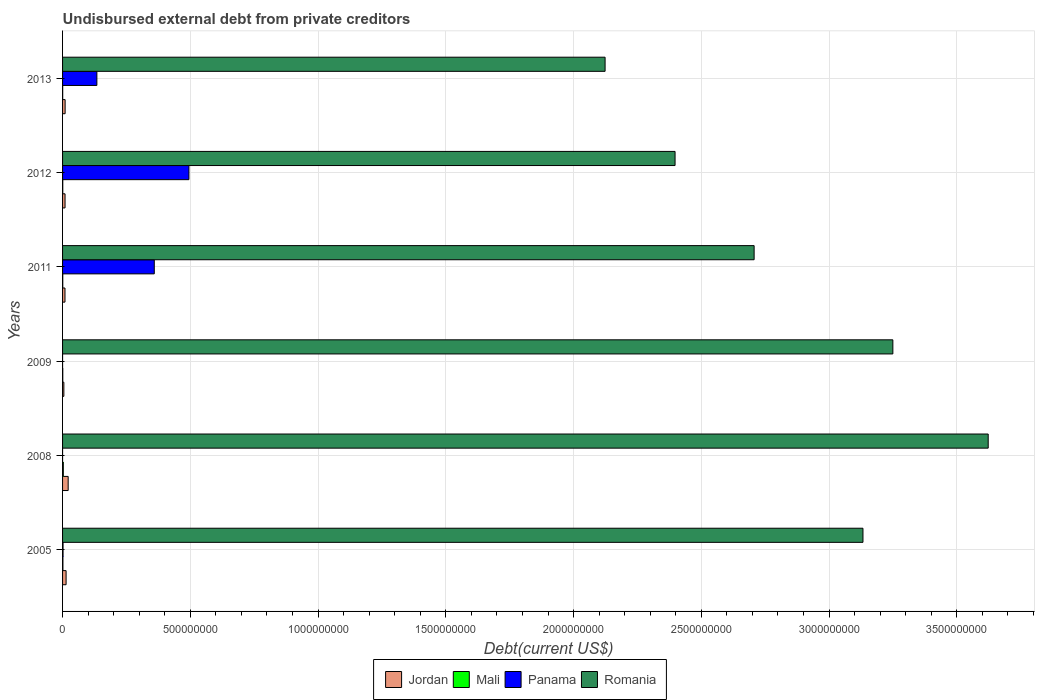How many groups of bars are there?
Offer a very short reply. 6. Are the number of bars on each tick of the Y-axis equal?
Your response must be concise. Yes. How many bars are there on the 2nd tick from the top?
Provide a short and direct response. 4. How many bars are there on the 6th tick from the bottom?
Offer a very short reply. 4. What is the total debt in Mali in 2005?
Make the answer very short. 1.38e+06. Across all years, what is the maximum total debt in Mali?
Ensure brevity in your answer.  2.91e+06. Across all years, what is the minimum total debt in Mali?
Give a very brief answer. 4.71e+05. What is the total total debt in Mali in the graph?
Provide a short and direct response. 7.16e+06. What is the difference between the total debt in Romania in 2008 and that in 2013?
Your answer should be very brief. 1.50e+09. What is the difference between the total debt in Jordan in 2005 and the total debt in Mali in 2012?
Your answer should be compact. 1.31e+07. What is the average total debt in Panama per year?
Offer a terse response. 1.65e+08. In the year 2011, what is the difference between the total debt in Romania and total debt in Mali?
Ensure brevity in your answer.  2.71e+09. In how many years, is the total debt in Romania greater than 1200000000 US$?
Your answer should be compact. 6. What is the ratio of the total debt in Mali in 2011 to that in 2013?
Your response must be concise. 1.61. Is the total debt in Romania in 2005 less than that in 2013?
Provide a short and direct response. No. Is the difference between the total debt in Romania in 2008 and 2012 greater than the difference between the total debt in Mali in 2008 and 2012?
Your answer should be compact. Yes. What is the difference between the highest and the second highest total debt in Jordan?
Offer a terse response. 8.09e+06. What is the difference between the highest and the lowest total debt in Romania?
Keep it short and to the point. 1.50e+09. In how many years, is the total debt in Romania greater than the average total debt in Romania taken over all years?
Offer a very short reply. 3. Is the sum of the total debt in Jordan in 2008 and 2013 greater than the maximum total debt in Romania across all years?
Ensure brevity in your answer.  No. What does the 3rd bar from the top in 2012 represents?
Ensure brevity in your answer.  Mali. What does the 1st bar from the bottom in 2005 represents?
Keep it short and to the point. Jordan. How many bars are there?
Ensure brevity in your answer.  24. Are all the bars in the graph horizontal?
Keep it short and to the point. Yes. How many years are there in the graph?
Provide a short and direct response. 6. What is the difference between two consecutive major ticks on the X-axis?
Ensure brevity in your answer.  5.00e+08. Does the graph contain any zero values?
Give a very brief answer. No. Where does the legend appear in the graph?
Provide a succinct answer. Bottom center. How many legend labels are there?
Your answer should be compact. 4. How are the legend labels stacked?
Your answer should be very brief. Horizontal. What is the title of the graph?
Keep it short and to the point. Undisbursed external debt from private creditors. Does "Bhutan" appear as one of the legend labels in the graph?
Give a very brief answer. No. What is the label or title of the X-axis?
Your answer should be very brief. Debt(current US$). What is the label or title of the Y-axis?
Provide a succinct answer. Years. What is the Debt(current US$) of Jordan in 2005?
Your response must be concise. 1.38e+07. What is the Debt(current US$) in Mali in 2005?
Your response must be concise. 1.38e+06. What is the Debt(current US$) of Panama in 2005?
Offer a terse response. 1.90e+06. What is the Debt(current US$) in Romania in 2005?
Provide a succinct answer. 3.13e+09. What is the Debt(current US$) of Jordan in 2008?
Your answer should be compact. 2.19e+07. What is the Debt(current US$) of Mali in 2008?
Offer a very short reply. 2.91e+06. What is the Debt(current US$) of Panama in 2008?
Make the answer very short. 2000. What is the Debt(current US$) of Romania in 2008?
Offer a terse response. 3.62e+09. What is the Debt(current US$) of Jordan in 2009?
Your answer should be very brief. 5.06e+06. What is the Debt(current US$) of Mali in 2009?
Keep it short and to the point. 8.62e+05. What is the Debt(current US$) in Panama in 2009?
Offer a very short reply. 2000. What is the Debt(current US$) in Romania in 2009?
Your answer should be compact. 3.25e+09. What is the Debt(current US$) of Jordan in 2011?
Provide a short and direct response. 9.48e+06. What is the Debt(current US$) in Mali in 2011?
Ensure brevity in your answer.  7.57e+05. What is the Debt(current US$) of Panama in 2011?
Your answer should be compact. 3.59e+08. What is the Debt(current US$) in Romania in 2011?
Offer a terse response. 2.71e+09. What is the Debt(current US$) in Jordan in 2012?
Your answer should be compact. 9.72e+06. What is the Debt(current US$) in Mali in 2012?
Give a very brief answer. 7.72e+05. What is the Debt(current US$) of Panama in 2012?
Your answer should be very brief. 4.95e+08. What is the Debt(current US$) in Romania in 2012?
Provide a succinct answer. 2.40e+09. What is the Debt(current US$) of Jordan in 2013?
Make the answer very short. 1.00e+07. What is the Debt(current US$) of Mali in 2013?
Offer a very short reply. 4.71e+05. What is the Debt(current US$) of Panama in 2013?
Provide a short and direct response. 1.34e+08. What is the Debt(current US$) in Romania in 2013?
Keep it short and to the point. 2.12e+09. Across all years, what is the maximum Debt(current US$) of Jordan?
Provide a short and direct response. 2.19e+07. Across all years, what is the maximum Debt(current US$) of Mali?
Offer a very short reply. 2.91e+06. Across all years, what is the maximum Debt(current US$) in Panama?
Your response must be concise. 4.95e+08. Across all years, what is the maximum Debt(current US$) of Romania?
Provide a short and direct response. 3.62e+09. Across all years, what is the minimum Debt(current US$) in Jordan?
Provide a short and direct response. 5.06e+06. Across all years, what is the minimum Debt(current US$) of Mali?
Your response must be concise. 4.71e+05. Across all years, what is the minimum Debt(current US$) of Panama?
Provide a succinct answer. 2000. Across all years, what is the minimum Debt(current US$) of Romania?
Ensure brevity in your answer.  2.12e+09. What is the total Debt(current US$) in Jordan in the graph?
Keep it short and to the point. 7.00e+07. What is the total Debt(current US$) of Mali in the graph?
Provide a short and direct response. 7.16e+06. What is the total Debt(current US$) in Panama in the graph?
Keep it short and to the point. 9.90e+08. What is the total Debt(current US$) of Romania in the graph?
Offer a very short reply. 1.72e+1. What is the difference between the Debt(current US$) in Jordan in 2005 and that in 2008?
Provide a short and direct response. -8.09e+06. What is the difference between the Debt(current US$) in Mali in 2005 and that in 2008?
Give a very brief answer. -1.52e+06. What is the difference between the Debt(current US$) of Panama in 2005 and that in 2008?
Ensure brevity in your answer.  1.90e+06. What is the difference between the Debt(current US$) in Romania in 2005 and that in 2008?
Keep it short and to the point. -4.90e+08. What is the difference between the Debt(current US$) of Jordan in 2005 and that in 2009?
Ensure brevity in your answer.  8.78e+06. What is the difference between the Debt(current US$) of Mali in 2005 and that in 2009?
Your response must be concise. 5.23e+05. What is the difference between the Debt(current US$) in Panama in 2005 and that in 2009?
Give a very brief answer. 1.90e+06. What is the difference between the Debt(current US$) of Romania in 2005 and that in 2009?
Your answer should be compact. -1.17e+08. What is the difference between the Debt(current US$) of Jordan in 2005 and that in 2011?
Keep it short and to the point. 4.36e+06. What is the difference between the Debt(current US$) in Mali in 2005 and that in 2011?
Provide a succinct answer. 6.28e+05. What is the difference between the Debt(current US$) in Panama in 2005 and that in 2011?
Ensure brevity in your answer.  -3.57e+08. What is the difference between the Debt(current US$) in Romania in 2005 and that in 2011?
Give a very brief answer. 4.26e+08. What is the difference between the Debt(current US$) of Jordan in 2005 and that in 2012?
Your answer should be compact. 4.12e+06. What is the difference between the Debt(current US$) of Mali in 2005 and that in 2012?
Offer a very short reply. 6.13e+05. What is the difference between the Debt(current US$) in Panama in 2005 and that in 2012?
Your answer should be very brief. -4.93e+08. What is the difference between the Debt(current US$) in Romania in 2005 and that in 2012?
Give a very brief answer. 7.35e+08. What is the difference between the Debt(current US$) in Jordan in 2005 and that in 2013?
Provide a succinct answer. 3.84e+06. What is the difference between the Debt(current US$) in Mali in 2005 and that in 2013?
Give a very brief answer. 9.14e+05. What is the difference between the Debt(current US$) of Panama in 2005 and that in 2013?
Offer a terse response. -1.32e+08. What is the difference between the Debt(current US$) in Romania in 2005 and that in 2013?
Your response must be concise. 1.01e+09. What is the difference between the Debt(current US$) in Jordan in 2008 and that in 2009?
Provide a short and direct response. 1.69e+07. What is the difference between the Debt(current US$) of Mali in 2008 and that in 2009?
Your answer should be very brief. 2.05e+06. What is the difference between the Debt(current US$) of Panama in 2008 and that in 2009?
Give a very brief answer. 0. What is the difference between the Debt(current US$) in Romania in 2008 and that in 2009?
Your answer should be compact. 3.73e+08. What is the difference between the Debt(current US$) of Jordan in 2008 and that in 2011?
Keep it short and to the point. 1.24e+07. What is the difference between the Debt(current US$) in Mali in 2008 and that in 2011?
Give a very brief answer. 2.15e+06. What is the difference between the Debt(current US$) of Panama in 2008 and that in 2011?
Make the answer very short. -3.59e+08. What is the difference between the Debt(current US$) of Romania in 2008 and that in 2011?
Provide a succinct answer. 9.16e+08. What is the difference between the Debt(current US$) in Jordan in 2008 and that in 2012?
Your answer should be compact. 1.22e+07. What is the difference between the Debt(current US$) in Mali in 2008 and that in 2012?
Your answer should be very brief. 2.14e+06. What is the difference between the Debt(current US$) in Panama in 2008 and that in 2012?
Provide a succinct answer. -4.95e+08. What is the difference between the Debt(current US$) of Romania in 2008 and that in 2012?
Your answer should be very brief. 1.23e+09. What is the difference between the Debt(current US$) of Jordan in 2008 and that in 2013?
Offer a terse response. 1.19e+07. What is the difference between the Debt(current US$) of Mali in 2008 and that in 2013?
Offer a terse response. 2.44e+06. What is the difference between the Debt(current US$) of Panama in 2008 and that in 2013?
Your response must be concise. -1.34e+08. What is the difference between the Debt(current US$) of Romania in 2008 and that in 2013?
Make the answer very short. 1.50e+09. What is the difference between the Debt(current US$) in Jordan in 2009 and that in 2011?
Offer a very short reply. -4.42e+06. What is the difference between the Debt(current US$) in Mali in 2009 and that in 2011?
Provide a succinct answer. 1.05e+05. What is the difference between the Debt(current US$) of Panama in 2009 and that in 2011?
Keep it short and to the point. -3.59e+08. What is the difference between the Debt(current US$) of Romania in 2009 and that in 2011?
Your answer should be compact. 5.43e+08. What is the difference between the Debt(current US$) of Jordan in 2009 and that in 2012?
Your answer should be compact. -4.66e+06. What is the difference between the Debt(current US$) of Panama in 2009 and that in 2012?
Provide a succinct answer. -4.95e+08. What is the difference between the Debt(current US$) in Romania in 2009 and that in 2012?
Your response must be concise. 8.52e+08. What is the difference between the Debt(current US$) of Jordan in 2009 and that in 2013?
Your answer should be compact. -4.94e+06. What is the difference between the Debt(current US$) of Mali in 2009 and that in 2013?
Provide a succinct answer. 3.91e+05. What is the difference between the Debt(current US$) of Panama in 2009 and that in 2013?
Keep it short and to the point. -1.34e+08. What is the difference between the Debt(current US$) in Romania in 2009 and that in 2013?
Keep it short and to the point. 1.13e+09. What is the difference between the Debt(current US$) of Jordan in 2011 and that in 2012?
Provide a succinct answer. -2.43e+05. What is the difference between the Debt(current US$) in Mali in 2011 and that in 2012?
Your answer should be very brief. -1.50e+04. What is the difference between the Debt(current US$) of Panama in 2011 and that in 2012?
Your answer should be very brief. -1.36e+08. What is the difference between the Debt(current US$) in Romania in 2011 and that in 2012?
Keep it short and to the point. 3.09e+08. What is the difference between the Debt(current US$) of Jordan in 2011 and that in 2013?
Offer a very short reply. -5.22e+05. What is the difference between the Debt(current US$) of Mali in 2011 and that in 2013?
Ensure brevity in your answer.  2.86e+05. What is the difference between the Debt(current US$) of Panama in 2011 and that in 2013?
Your response must be concise. 2.25e+08. What is the difference between the Debt(current US$) in Romania in 2011 and that in 2013?
Your answer should be very brief. 5.83e+08. What is the difference between the Debt(current US$) of Jordan in 2012 and that in 2013?
Your response must be concise. -2.79e+05. What is the difference between the Debt(current US$) of Mali in 2012 and that in 2013?
Offer a terse response. 3.01e+05. What is the difference between the Debt(current US$) of Panama in 2012 and that in 2013?
Provide a succinct answer. 3.60e+08. What is the difference between the Debt(current US$) in Romania in 2012 and that in 2013?
Keep it short and to the point. 2.74e+08. What is the difference between the Debt(current US$) of Jordan in 2005 and the Debt(current US$) of Mali in 2008?
Provide a short and direct response. 1.09e+07. What is the difference between the Debt(current US$) of Jordan in 2005 and the Debt(current US$) of Panama in 2008?
Give a very brief answer. 1.38e+07. What is the difference between the Debt(current US$) in Jordan in 2005 and the Debt(current US$) in Romania in 2008?
Provide a short and direct response. -3.61e+09. What is the difference between the Debt(current US$) of Mali in 2005 and the Debt(current US$) of Panama in 2008?
Offer a terse response. 1.38e+06. What is the difference between the Debt(current US$) of Mali in 2005 and the Debt(current US$) of Romania in 2008?
Provide a succinct answer. -3.62e+09. What is the difference between the Debt(current US$) of Panama in 2005 and the Debt(current US$) of Romania in 2008?
Offer a terse response. -3.62e+09. What is the difference between the Debt(current US$) of Jordan in 2005 and the Debt(current US$) of Mali in 2009?
Offer a very short reply. 1.30e+07. What is the difference between the Debt(current US$) of Jordan in 2005 and the Debt(current US$) of Panama in 2009?
Make the answer very short. 1.38e+07. What is the difference between the Debt(current US$) in Jordan in 2005 and the Debt(current US$) in Romania in 2009?
Your answer should be compact. -3.24e+09. What is the difference between the Debt(current US$) of Mali in 2005 and the Debt(current US$) of Panama in 2009?
Offer a terse response. 1.38e+06. What is the difference between the Debt(current US$) in Mali in 2005 and the Debt(current US$) in Romania in 2009?
Make the answer very short. -3.25e+09. What is the difference between the Debt(current US$) in Panama in 2005 and the Debt(current US$) in Romania in 2009?
Give a very brief answer. -3.25e+09. What is the difference between the Debt(current US$) in Jordan in 2005 and the Debt(current US$) in Mali in 2011?
Provide a short and direct response. 1.31e+07. What is the difference between the Debt(current US$) in Jordan in 2005 and the Debt(current US$) in Panama in 2011?
Make the answer very short. -3.45e+08. What is the difference between the Debt(current US$) in Jordan in 2005 and the Debt(current US$) in Romania in 2011?
Provide a short and direct response. -2.69e+09. What is the difference between the Debt(current US$) in Mali in 2005 and the Debt(current US$) in Panama in 2011?
Provide a short and direct response. -3.58e+08. What is the difference between the Debt(current US$) of Mali in 2005 and the Debt(current US$) of Romania in 2011?
Your answer should be very brief. -2.71e+09. What is the difference between the Debt(current US$) of Panama in 2005 and the Debt(current US$) of Romania in 2011?
Offer a terse response. -2.70e+09. What is the difference between the Debt(current US$) of Jordan in 2005 and the Debt(current US$) of Mali in 2012?
Offer a terse response. 1.31e+07. What is the difference between the Debt(current US$) in Jordan in 2005 and the Debt(current US$) in Panama in 2012?
Your response must be concise. -4.81e+08. What is the difference between the Debt(current US$) in Jordan in 2005 and the Debt(current US$) in Romania in 2012?
Ensure brevity in your answer.  -2.38e+09. What is the difference between the Debt(current US$) of Mali in 2005 and the Debt(current US$) of Panama in 2012?
Provide a succinct answer. -4.93e+08. What is the difference between the Debt(current US$) of Mali in 2005 and the Debt(current US$) of Romania in 2012?
Make the answer very short. -2.40e+09. What is the difference between the Debt(current US$) of Panama in 2005 and the Debt(current US$) of Romania in 2012?
Provide a succinct answer. -2.40e+09. What is the difference between the Debt(current US$) in Jordan in 2005 and the Debt(current US$) in Mali in 2013?
Give a very brief answer. 1.34e+07. What is the difference between the Debt(current US$) in Jordan in 2005 and the Debt(current US$) in Panama in 2013?
Ensure brevity in your answer.  -1.20e+08. What is the difference between the Debt(current US$) of Jordan in 2005 and the Debt(current US$) of Romania in 2013?
Make the answer very short. -2.11e+09. What is the difference between the Debt(current US$) in Mali in 2005 and the Debt(current US$) in Panama in 2013?
Your response must be concise. -1.33e+08. What is the difference between the Debt(current US$) of Mali in 2005 and the Debt(current US$) of Romania in 2013?
Provide a short and direct response. -2.12e+09. What is the difference between the Debt(current US$) of Panama in 2005 and the Debt(current US$) of Romania in 2013?
Your answer should be very brief. -2.12e+09. What is the difference between the Debt(current US$) in Jordan in 2008 and the Debt(current US$) in Mali in 2009?
Your response must be concise. 2.11e+07. What is the difference between the Debt(current US$) in Jordan in 2008 and the Debt(current US$) in Panama in 2009?
Keep it short and to the point. 2.19e+07. What is the difference between the Debt(current US$) of Jordan in 2008 and the Debt(current US$) of Romania in 2009?
Give a very brief answer. -3.23e+09. What is the difference between the Debt(current US$) of Mali in 2008 and the Debt(current US$) of Panama in 2009?
Provide a short and direct response. 2.91e+06. What is the difference between the Debt(current US$) of Mali in 2008 and the Debt(current US$) of Romania in 2009?
Your answer should be compact. -3.25e+09. What is the difference between the Debt(current US$) of Panama in 2008 and the Debt(current US$) of Romania in 2009?
Ensure brevity in your answer.  -3.25e+09. What is the difference between the Debt(current US$) in Jordan in 2008 and the Debt(current US$) in Mali in 2011?
Make the answer very short. 2.12e+07. What is the difference between the Debt(current US$) in Jordan in 2008 and the Debt(current US$) in Panama in 2011?
Provide a short and direct response. -3.37e+08. What is the difference between the Debt(current US$) in Jordan in 2008 and the Debt(current US$) in Romania in 2011?
Ensure brevity in your answer.  -2.68e+09. What is the difference between the Debt(current US$) of Mali in 2008 and the Debt(current US$) of Panama in 2011?
Ensure brevity in your answer.  -3.56e+08. What is the difference between the Debt(current US$) in Mali in 2008 and the Debt(current US$) in Romania in 2011?
Offer a terse response. -2.70e+09. What is the difference between the Debt(current US$) in Panama in 2008 and the Debt(current US$) in Romania in 2011?
Give a very brief answer. -2.71e+09. What is the difference between the Debt(current US$) in Jordan in 2008 and the Debt(current US$) in Mali in 2012?
Offer a very short reply. 2.12e+07. What is the difference between the Debt(current US$) in Jordan in 2008 and the Debt(current US$) in Panama in 2012?
Make the answer very short. -4.73e+08. What is the difference between the Debt(current US$) of Jordan in 2008 and the Debt(current US$) of Romania in 2012?
Your answer should be very brief. -2.38e+09. What is the difference between the Debt(current US$) of Mali in 2008 and the Debt(current US$) of Panama in 2012?
Give a very brief answer. -4.92e+08. What is the difference between the Debt(current US$) of Mali in 2008 and the Debt(current US$) of Romania in 2012?
Provide a short and direct response. -2.39e+09. What is the difference between the Debt(current US$) of Panama in 2008 and the Debt(current US$) of Romania in 2012?
Your answer should be very brief. -2.40e+09. What is the difference between the Debt(current US$) in Jordan in 2008 and the Debt(current US$) in Mali in 2013?
Your response must be concise. 2.15e+07. What is the difference between the Debt(current US$) of Jordan in 2008 and the Debt(current US$) of Panama in 2013?
Give a very brief answer. -1.12e+08. What is the difference between the Debt(current US$) in Jordan in 2008 and the Debt(current US$) in Romania in 2013?
Your answer should be very brief. -2.10e+09. What is the difference between the Debt(current US$) in Mali in 2008 and the Debt(current US$) in Panama in 2013?
Ensure brevity in your answer.  -1.31e+08. What is the difference between the Debt(current US$) of Mali in 2008 and the Debt(current US$) of Romania in 2013?
Offer a terse response. -2.12e+09. What is the difference between the Debt(current US$) in Panama in 2008 and the Debt(current US$) in Romania in 2013?
Your answer should be very brief. -2.12e+09. What is the difference between the Debt(current US$) of Jordan in 2009 and the Debt(current US$) of Mali in 2011?
Your answer should be compact. 4.30e+06. What is the difference between the Debt(current US$) of Jordan in 2009 and the Debt(current US$) of Panama in 2011?
Your answer should be very brief. -3.54e+08. What is the difference between the Debt(current US$) of Jordan in 2009 and the Debt(current US$) of Romania in 2011?
Provide a succinct answer. -2.70e+09. What is the difference between the Debt(current US$) of Mali in 2009 and the Debt(current US$) of Panama in 2011?
Make the answer very short. -3.58e+08. What is the difference between the Debt(current US$) in Mali in 2009 and the Debt(current US$) in Romania in 2011?
Ensure brevity in your answer.  -2.71e+09. What is the difference between the Debt(current US$) of Panama in 2009 and the Debt(current US$) of Romania in 2011?
Offer a very short reply. -2.71e+09. What is the difference between the Debt(current US$) in Jordan in 2009 and the Debt(current US$) in Mali in 2012?
Provide a succinct answer. 4.29e+06. What is the difference between the Debt(current US$) of Jordan in 2009 and the Debt(current US$) of Panama in 2012?
Provide a short and direct response. -4.90e+08. What is the difference between the Debt(current US$) in Jordan in 2009 and the Debt(current US$) in Romania in 2012?
Keep it short and to the point. -2.39e+09. What is the difference between the Debt(current US$) in Mali in 2009 and the Debt(current US$) in Panama in 2012?
Keep it short and to the point. -4.94e+08. What is the difference between the Debt(current US$) in Mali in 2009 and the Debt(current US$) in Romania in 2012?
Offer a very short reply. -2.40e+09. What is the difference between the Debt(current US$) in Panama in 2009 and the Debt(current US$) in Romania in 2012?
Offer a very short reply. -2.40e+09. What is the difference between the Debt(current US$) in Jordan in 2009 and the Debt(current US$) in Mali in 2013?
Your answer should be compact. 4.59e+06. What is the difference between the Debt(current US$) in Jordan in 2009 and the Debt(current US$) in Panama in 2013?
Your answer should be compact. -1.29e+08. What is the difference between the Debt(current US$) of Jordan in 2009 and the Debt(current US$) of Romania in 2013?
Your response must be concise. -2.12e+09. What is the difference between the Debt(current US$) in Mali in 2009 and the Debt(current US$) in Panama in 2013?
Ensure brevity in your answer.  -1.33e+08. What is the difference between the Debt(current US$) in Mali in 2009 and the Debt(current US$) in Romania in 2013?
Provide a succinct answer. -2.12e+09. What is the difference between the Debt(current US$) of Panama in 2009 and the Debt(current US$) of Romania in 2013?
Give a very brief answer. -2.12e+09. What is the difference between the Debt(current US$) of Jordan in 2011 and the Debt(current US$) of Mali in 2012?
Keep it short and to the point. 8.70e+06. What is the difference between the Debt(current US$) of Jordan in 2011 and the Debt(current US$) of Panama in 2012?
Give a very brief answer. -4.85e+08. What is the difference between the Debt(current US$) of Jordan in 2011 and the Debt(current US$) of Romania in 2012?
Your answer should be very brief. -2.39e+09. What is the difference between the Debt(current US$) in Mali in 2011 and the Debt(current US$) in Panama in 2012?
Your answer should be very brief. -4.94e+08. What is the difference between the Debt(current US$) in Mali in 2011 and the Debt(current US$) in Romania in 2012?
Provide a succinct answer. -2.40e+09. What is the difference between the Debt(current US$) in Panama in 2011 and the Debt(current US$) in Romania in 2012?
Your answer should be very brief. -2.04e+09. What is the difference between the Debt(current US$) of Jordan in 2011 and the Debt(current US$) of Mali in 2013?
Your answer should be compact. 9.00e+06. What is the difference between the Debt(current US$) of Jordan in 2011 and the Debt(current US$) of Panama in 2013?
Your answer should be very brief. -1.25e+08. What is the difference between the Debt(current US$) of Jordan in 2011 and the Debt(current US$) of Romania in 2013?
Offer a very short reply. -2.11e+09. What is the difference between the Debt(current US$) of Mali in 2011 and the Debt(current US$) of Panama in 2013?
Offer a terse response. -1.34e+08. What is the difference between the Debt(current US$) in Mali in 2011 and the Debt(current US$) in Romania in 2013?
Your response must be concise. -2.12e+09. What is the difference between the Debt(current US$) of Panama in 2011 and the Debt(current US$) of Romania in 2013?
Your answer should be very brief. -1.76e+09. What is the difference between the Debt(current US$) of Jordan in 2012 and the Debt(current US$) of Mali in 2013?
Offer a terse response. 9.25e+06. What is the difference between the Debt(current US$) of Jordan in 2012 and the Debt(current US$) of Panama in 2013?
Make the answer very short. -1.25e+08. What is the difference between the Debt(current US$) in Jordan in 2012 and the Debt(current US$) in Romania in 2013?
Keep it short and to the point. -2.11e+09. What is the difference between the Debt(current US$) of Mali in 2012 and the Debt(current US$) of Panama in 2013?
Your answer should be very brief. -1.34e+08. What is the difference between the Debt(current US$) of Mali in 2012 and the Debt(current US$) of Romania in 2013?
Provide a short and direct response. -2.12e+09. What is the difference between the Debt(current US$) in Panama in 2012 and the Debt(current US$) in Romania in 2013?
Keep it short and to the point. -1.63e+09. What is the average Debt(current US$) of Jordan per year?
Ensure brevity in your answer.  1.17e+07. What is the average Debt(current US$) in Mali per year?
Make the answer very short. 1.19e+06. What is the average Debt(current US$) in Panama per year?
Provide a short and direct response. 1.65e+08. What is the average Debt(current US$) in Romania per year?
Offer a terse response. 2.87e+09. In the year 2005, what is the difference between the Debt(current US$) of Jordan and Debt(current US$) of Mali?
Make the answer very short. 1.25e+07. In the year 2005, what is the difference between the Debt(current US$) of Jordan and Debt(current US$) of Panama?
Your response must be concise. 1.19e+07. In the year 2005, what is the difference between the Debt(current US$) in Jordan and Debt(current US$) in Romania?
Your answer should be very brief. -3.12e+09. In the year 2005, what is the difference between the Debt(current US$) of Mali and Debt(current US$) of Panama?
Your response must be concise. -5.18e+05. In the year 2005, what is the difference between the Debt(current US$) in Mali and Debt(current US$) in Romania?
Ensure brevity in your answer.  -3.13e+09. In the year 2005, what is the difference between the Debt(current US$) of Panama and Debt(current US$) of Romania?
Keep it short and to the point. -3.13e+09. In the year 2008, what is the difference between the Debt(current US$) in Jordan and Debt(current US$) in Mali?
Provide a short and direct response. 1.90e+07. In the year 2008, what is the difference between the Debt(current US$) in Jordan and Debt(current US$) in Panama?
Keep it short and to the point. 2.19e+07. In the year 2008, what is the difference between the Debt(current US$) in Jordan and Debt(current US$) in Romania?
Your answer should be very brief. -3.60e+09. In the year 2008, what is the difference between the Debt(current US$) in Mali and Debt(current US$) in Panama?
Offer a very short reply. 2.91e+06. In the year 2008, what is the difference between the Debt(current US$) in Mali and Debt(current US$) in Romania?
Give a very brief answer. -3.62e+09. In the year 2008, what is the difference between the Debt(current US$) of Panama and Debt(current US$) of Romania?
Your answer should be compact. -3.62e+09. In the year 2009, what is the difference between the Debt(current US$) in Jordan and Debt(current US$) in Mali?
Offer a terse response. 4.20e+06. In the year 2009, what is the difference between the Debt(current US$) of Jordan and Debt(current US$) of Panama?
Keep it short and to the point. 5.06e+06. In the year 2009, what is the difference between the Debt(current US$) of Jordan and Debt(current US$) of Romania?
Make the answer very short. -3.24e+09. In the year 2009, what is the difference between the Debt(current US$) in Mali and Debt(current US$) in Panama?
Give a very brief answer. 8.60e+05. In the year 2009, what is the difference between the Debt(current US$) of Mali and Debt(current US$) of Romania?
Your answer should be compact. -3.25e+09. In the year 2009, what is the difference between the Debt(current US$) of Panama and Debt(current US$) of Romania?
Make the answer very short. -3.25e+09. In the year 2011, what is the difference between the Debt(current US$) in Jordan and Debt(current US$) in Mali?
Offer a terse response. 8.72e+06. In the year 2011, what is the difference between the Debt(current US$) in Jordan and Debt(current US$) in Panama?
Make the answer very short. -3.50e+08. In the year 2011, what is the difference between the Debt(current US$) in Jordan and Debt(current US$) in Romania?
Provide a succinct answer. -2.70e+09. In the year 2011, what is the difference between the Debt(current US$) in Mali and Debt(current US$) in Panama?
Give a very brief answer. -3.58e+08. In the year 2011, what is the difference between the Debt(current US$) of Mali and Debt(current US$) of Romania?
Your response must be concise. -2.71e+09. In the year 2011, what is the difference between the Debt(current US$) in Panama and Debt(current US$) in Romania?
Offer a terse response. -2.35e+09. In the year 2012, what is the difference between the Debt(current US$) in Jordan and Debt(current US$) in Mali?
Provide a short and direct response. 8.95e+06. In the year 2012, what is the difference between the Debt(current US$) in Jordan and Debt(current US$) in Panama?
Ensure brevity in your answer.  -4.85e+08. In the year 2012, what is the difference between the Debt(current US$) of Jordan and Debt(current US$) of Romania?
Offer a terse response. -2.39e+09. In the year 2012, what is the difference between the Debt(current US$) of Mali and Debt(current US$) of Panama?
Provide a short and direct response. -4.94e+08. In the year 2012, what is the difference between the Debt(current US$) of Mali and Debt(current US$) of Romania?
Offer a very short reply. -2.40e+09. In the year 2012, what is the difference between the Debt(current US$) of Panama and Debt(current US$) of Romania?
Offer a terse response. -1.90e+09. In the year 2013, what is the difference between the Debt(current US$) of Jordan and Debt(current US$) of Mali?
Make the answer very short. 9.53e+06. In the year 2013, what is the difference between the Debt(current US$) of Jordan and Debt(current US$) of Panama?
Offer a very short reply. -1.24e+08. In the year 2013, what is the difference between the Debt(current US$) in Jordan and Debt(current US$) in Romania?
Your answer should be very brief. -2.11e+09. In the year 2013, what is the difference between the Debt(current US$) of Mali and Debt(current US$) of Panama?
Ensure brevity in your answer.  -1.34e+08. In the year 2013, what is the difference between the Debt(current US$) of Mali and Debt(current US$) of Romania?
Ensure brevity in your answer.  -2.12e+09. In the year 2013, what is the difference between the Debt(current US$) of Panama and Debt(current US$) of Romania?
Your response must be concise. -1.99e+09. What is the ratio of the Debt(current US$) of Jordan in 2005 to that in 2008?
Your response must be concise. 0.63. What is the ratio of the Debt(current US$) in Mali in 2005 to that in 2008?
Your answer should be compact. 0.48. What is the ratio of the Debt(current US$) in Panama in 2005 to that in 2008?
Your response must be concise. 951.5. What is the ratio of the Debt(current US$) in Romania in 2005 to that in 2008?
Your answer should be very brief. 0.86. What is the ratio of the Debt(current US$) of Jordan in 2005 to that in 2009?
Ensure brevity in your answer.  2.73. What is the ratio of the Debt(current US$) in Mali in 2005 to that in 2009?
Make the answer very short. 1.61. What is the ratio of the Debt(current US$) of Panama in 2005 to that in 2009?
Offer a very short reply. 951.5. What is the ratio of the Debt(current US$) in Jordan in 2005 to that in 2011?
Give a very brief answer. 1.46. What is the ratio of the Debt(current US$) of Mali in 2005 to that in 2011?
Ensure brevity in your answer.  1.83. What is the ratio of the Debt(current US$) in Panama in 2005 to that in 2011?
Offer a terse response. 0.01. What is the ratio of the Debt(current US$) of Romania in 2005 to that in 2011?
Your answer should be compact. 1.16. What is the ratio of the Debt(current US$) of Jordan in 2005 to that in 2012?
Offer a very short reply. 1.42. What is the ratio of the Debt(current US$) in Mali in 2005 to that in 2012?
Offer a very short reply. 1.79. What is the ratio of the Debt(current US$) in Panama in 2005 to that in 2012?
Your answer should be very brief. 0. What is the ratio of the Debt(current US$) of Romania in 2005 to that in 2012?
Provide a succinct answer. 1.31. What is the ratio of the Debt(current US$) in Jordan in 2005 to that in 2013?
Offer a very short reply. 1.38. What is the ratio of the Debt(current US$) in Mali in 2005 to that in 2013?
Your answer should be very brief. 2.94. What is the ratio of the Debt(current US$) in Panama in 2005 to that in 2013?
Offer a very short reply. 0.01. What is the ratio of the Debt(current US$) in Romania in 2005 to that in 2013?
Keep it short and to the point. 1.48. What is the ratio of the Debt(current US$) of Jordan in 2008 to that in 2009?
Offer a very short reply. 4.33. What is the ratio of the Debt(current US$) of Mali in 2008 to that in 2009?
Your response must be concise. 3.37. What is the ratio of the Debt(current US$) in Romania in 2008 to that in 2009?
Offer a very short reply. 1.11. What is the ratio of the Debt(current US$) of Jordan in 2008 to that in 2011?
Offer a very short reply. 2.31. What is the ratio of the Debt(current US$) in Mali in 2008 to that in 2011?
Provide a succinct answer. 3.84. What is the ratio of the Debt(current US$) of Romania in 2008 to that in 2011?
Offer a terse response. 1.34. What is the ratio of the Debt(current US$) of Jordan in 2008 to that in 2012?
Keep it short and to the point. 2.26. What is the ratio of the Debt(current US$) in Mali in 2008 to that in 2012?
Ensure brevity in your answer.  3.77. What is the ratio of the Debt(current US$) in Romania in 2008 to that in 2012?
Ensure brevity in your answer.  1.51. What is the ratio of the Debt(current US$) in Jordan in 2008 to that in 2013?
Your answer should be very brief. 2.19. What is the ratio of the Debt(current US$) of Mali in 2008 to that in 2013?
Give a very brief answer. 6.17. What is the ratio of the Debt(current US$) in Panama in 2008 to that in 2013?
Your response must be concise. 0. What is the ratio of the Debt(current US$) of Romania in 2008 to that in 2013?
Offer a terse response. 1.71. What is the ratio of the Debt(current US$) of Jordan in 2009 to that in 2011?
Provide a short and direct response. 0.53. What is the ratio of the Debt(current US$) in Mali in 2009 to that in 2011?
Offer a terse response. 1.14. What is the ratio of the Debt(current US$) in Romania in 2009 to that in 2011?
Your answer should be very brief. 1.2. What is the ratio of the Debt(current US$) in Jordan in 2009 to that in 2012?
Your answer should be very brief. 0.52. What is the ratio of the Debt(current US$) in Mali in 2009 to that in 2012?
Ensure brevity in your answer.  1.12. What is the ratio of the Debt(current US$) in Panama in 2009 to that in 2012?
Offer a terse response. 0. What is the ratio of the Debt(current US$) in Romania in 2009 to that in 2012?
Your answer should be compact. 1.36. What is the ratio of the Debt(current US$) of Jordan in 2009 to that in 2013?
Your answer should be compact. 0.51. What is the ratio of the Debt(current US$) in Mali in 2009 to that in 2013?
Keep it short and to the point. 1.83. What is the ratio of the Debt(current US$) in Romania in 2009 to that in 2013?
Provide a succinct answer. 1.53. What is the ratio of the Debt(current US$) of Jordan in 2011 to that in 2012?
Keep it short and to the point. 0.97. What is the ratio of the Debt(current US$) in Mali in 2011 to that in 2012?
Keep it short and to the point. 0.98. What is the ratio of the Debt(current US$) of Panama in 2011 to that in 2012?
Give a very brief answer. 0.73. What is the ratio of the Debt(current US$) of Romania in 2011 to that in 2012?
Offer a terse response. 1.13. What is the ratio of the Debt(current US$) of Jordan in 2011 to that in 2013?
Your response must be concise. 0.95. What is the ratio of the Debt(current US$) of Mali in 2011 to that in 2013?
Keep it short and to the point. 1.61. What is the ratio of the Debt(current US$) in Panama in 2011 to that in 2013?
Your answer should be very brief. 2.67. What is the ratio of the Debt(current US$) in Romania in 2011 to that in 2013?
Give a very brief answer. 1.27. What is the ratio of the Debt(current US$) of Jordan in 2012 to that in 2013?
Make the answer very short. 0.97. What is the ratio of the Debt(current US$) of Mali in 2012 to that in 2013?
Your response must be concise. 1.64. What is the ratio of the Debt(current US$) of Panama in 2012 to that in 2013?
Ensure brevity in your answer.  3.68. What is the ratio of the Debt(current US$) in Romania in 2012 to that in 2013?
Make the answer very short. 1.13. What is the difference between the highest and the second highest Debt(current US$) of Jordan?
Keep it short and to the point. 8.09e+06. What is the difference between the highest and the second highest Debt(current US$) of Mali?
Give a very brief answer. 1.52e+06. What is the difference between the highest and the second highest Debt(current US$) in Panama?
Give a very brief answer. 1.36e+08. What is the difference between the highest and the second highest Debt(current US$) of Romania?
Provide a succinct answer. 3.73e+08. What is the difference between the highest and the lowest Debt(current US$) of Jordan?
Your answer should be very brief. 1.69e+07. What is the difference between the highest and the lowest Debt(current US$) in Mali?
Your response must be concise. 2.44e+06. What is the difference between the highest and the lowest Debt(current US$) of Panama?
Your answer should be compact. 4.95e+08. What is the difference between the highest and the lowest Debt(current US$) in Romania?
Ensure brevity in your answer.  1.50e+09. 